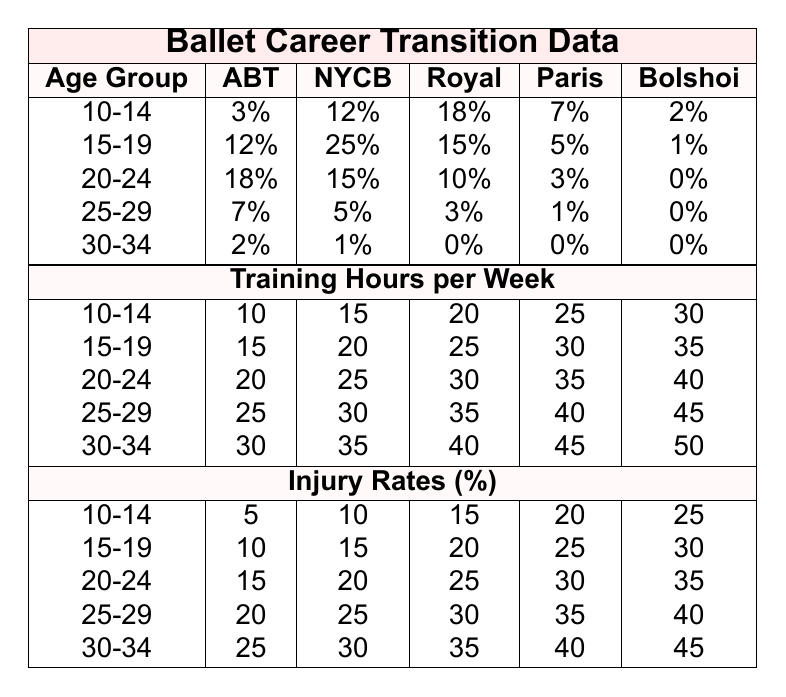What is the success rate for the age group 15-19 at the New York City Ballet? Referring to the table, the success rate for the age group 15-19 at the New York City Ballet is 25%.
Answer: 25% Which age group has the highest success rate at the Royal Ballet? Looking at the Royal Ballet's success rates, the age group 10-14 has the highest rate at 18%.
Answer: 18% What is the difference in success rates between the age groups 20-24 and 25-29 at the American Ballet Theatre? The success rate for age group 20-24 at the American Ballet Theatre is 18%, and for 25-29 it is 7%. The difference is 18% - 7% = 11%.
Answer: 11% What is the average success rate across all age groups at the Bolshoi Ballet? Adding the success rates for Bolshoi Ballet: 2% + 1% + 0% + 0% + 0% = 3%. There are 5 age groups, so the average is 3% / 5 = 0.6%.
Answer: 0.6% Is the injury rate for the age group 30-34 higher or lower than that for the age group 10-14? The injury rate for age group 30-34 is 25%, while for age group 10-14 it is 5%. Since 25% is greater than 5%, the injury rate for 30-34 is higher.
Answer: Higher What can be deduced about the relationship between training hours and success rates for the 20-24 age group? For the age group 20-24, training hours per week increase from 20 to 40, but success rates decrease from 18% to 10%. This suggests that more training hours do not necessarily correlate with higher success rates for this age group.
Answer: More training hours do not correlate positively with success rates What is the total success rate for the age group 10-14 across all ballet companies? Summing the success rates for age group 10-14: 3% + 12% + 18% + 7% + 2% gives 42%.
Answer: 42% Which ballet company has the lowest success rate for the age group 30-34? The success rates for age group 30-34 are: American Ballet Theatre at 2%, New York City Ballet at 1%, Royal at 0%, Paris at 0%, and Bolshoi at 0%. The lowest rates are all 0% at Royal, Paris, and Bolshoi.
Answer: Royal, Paris, and Bolshoi all have the lowest success rate of 0% How does the injury rate change with age groups? The injury rates increase with each age group, starting from 5% for 10-14 up to 45% for 30-34, indicating a rising trend in injury rates with age.
Answer: Injury rates increase with age groups What is the combined success rate of the age group 15-19 among all ballet companies? The success rates for age group 15-19 are: 12% (ABT) + 25% (NYCB) + 15% (Royal) + 5% (Paris) + 1% (Bolshoi), totaling 58%.
Answer: 58% 